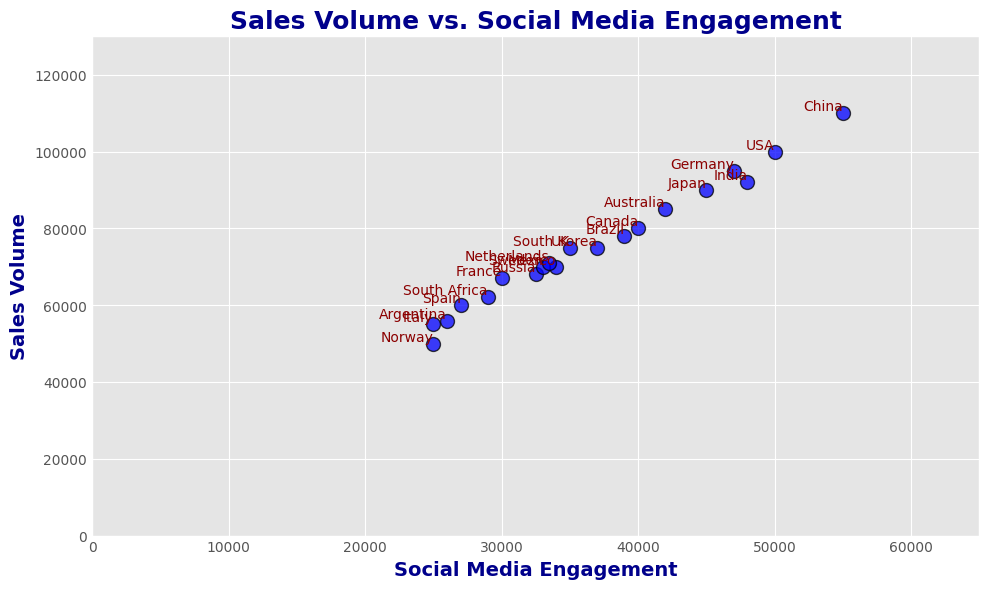Which country has the highest sales volume? The highest point on the Y-axis represents the highest sales volume. The label at this point indicates the country.
Answer: China Which country has the lowest social media engagement? The leftmost point on the X-axis represents the lowest social media engagement. The label at this point indicates the country.
Answer: Norway What is the average sales volume for the countries with more than 40,000 social media engagements? Identify the countries with more than 40,000 social media engagements (USA, Canada, Germany, Australia, Japan, India, China). Sum their sales volumes (100000 + 80000 + 95000 + 85000 + 90000 + 92000 + 110000 = 652000). Then divide by the number of countries (652000/7 ≈ 93143).
Answer: 93143 Which country has a higher social media engagement: Brazil or South Korea? Compare the X-values of the points labeled 'Brazil' and 'South Korea'. Brazil has 39,000, and South Korea has 37,000.
Answer: Brazil What is the sum of sales volumes for the countries with between 30,000 and 35,000 social media engagements? Identify the countries with social media engagements between 30,000 and 35,000 (France, Russia, Mexico, Sweden, Netherlands). Sum their sales volumes (67000 + 68000 + 70000 + 70000 + 71000 = 346000).
Answer: 346000 What is the difference in sales volume between France and Spain? Find the sales volumes for France (67,000) and Spain (60,000). Compute their difference (67000 - 60000 = 7000).
Answer: 7000 Which countries are clustered around a social media engagement of 25,000? Identify the points near the X-value of 25,000. Annotated labels indicate the countries (Italy, Norway).
Answer: Italy, Norway How does the sales volume of India compare to the sales volume of Japan? Compare the Y-values of the points labeled 'India' and 'Japan'. India has 92,000, and Japan has 90,000, so India has a higher sales volume.
Answer: India Is there a positive correlation between social media engagement and sales volume? Observe the trend of the scatter plot. Points generally move upwards with increasing X-values, indicating a positive correlation.
Answer: Yes 